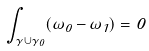<formula> <loc_0><loc_0><loc_500><loc_500>\int _ { \gamma \cup \gamma _ { 0 } } ( \omega _ { 0 } - \omega _ { 1 } ) = 0</formula> 